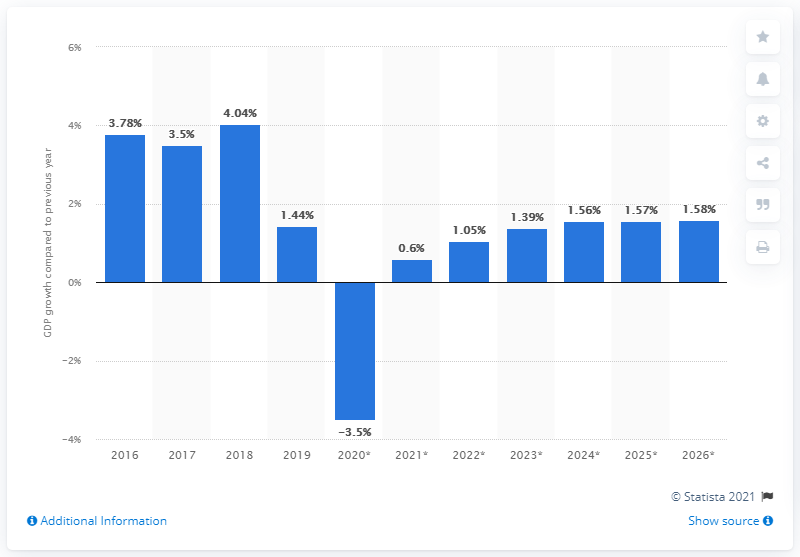Specify some key components in this picture. In 2019, Zambia's gross domestic product grew by 1.44%. 